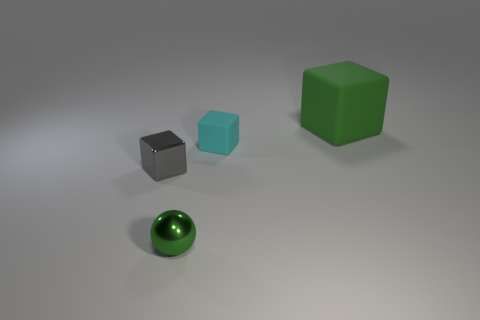What is the size of the thing that is the same color as the ball?
Provide a succinct answer. Large. Do the cyan matte block and the sphere have the same size?
Your answer should be very brief. Yes. Are there more shiny cubes left of the green cube than green spheres that are behind the ball?
Make the answer very short. Yes. How many other things are there of the same size as the green block?
Give a very brief answer. 0. Is the color of the matte object behind the small matte block the same as the metal ball?
Provide a succinct answer. Yes. Is the number of tiny gray things that are in front of the large green matte object greater than the number of large gray rubber balls?
Make the answer very short. Yes. Is there any other thing that has the same color as the sphere?
Offer a very short reply. Yes. There is a green thing that is left of the green object that is behind the small gray thing; what is its shape?
Your answer should be very brief. Sphere. Are there more blue rubber objects than small metallic balls?
Give a very brief answer. No. What number of things are behind the gray metallic block and on the left side of the green cube?
Offer a terse response. 1. 